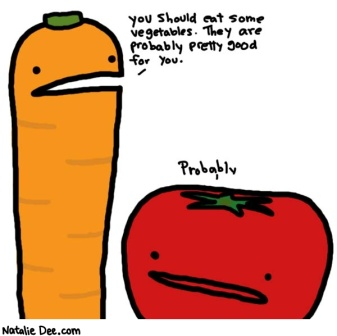Imagine the carrot and the tomato in a fantasy world. What kind of roles would they play? In a magical fantasy world, the carrot would be the wise and brave knight, armed with a sword made of iron-rich spinach and clad in armor crafted from the sturdiest beets. He would go by the name Sir Carrot, the Protector of Health, always ready to fight off evil junk food forces threatening the Kingdom of Nutritia.
The tomato would be the clever alchemist, known as Dr. Tomato, concocting powerful elixirs and potions from the finest garden herbs and spices. Using his vast knowledge, he would assist Sir Carrot on their quests, providing crucial support with his healing brews and wisdom.
Together, they would embark on epic adventures, ensuring the land remains healthy and prosperous, educating its citizens about the importance of balanced nutrition along the way.  Describe what a day in the life of these vegetable heroes would be like on their adventure. Sir Carrot and Dr. Tomato started their day by planning their journey in the vibrant garden kingdom of Nutritia. They reviewed their map, identifying areas plagued by the Mischief of Processed Food Goblins. After a hearty breakfast of leafy greens and root vegetables, they set off on their quest.
Sir Carrot led with strength and valor, his armor gleaming in the sunlight. He used his spinach sword to clear any obstacles and protect their path. Meanwhile, Dr. Tomato worked tirelessly to mix powerful potions from the garden flora, ready to restore their energy if needed.
As they traveled, they encountered citizens who needed their help. For instance, they met a group of young sprouts (baby veggies) feeling weak and tired. Dr. Tomato quickly brewed a vitamin-rich smoothie, instantly rejuvenating them. Sir Carrot offered advice on maintaining a nutritious diet as they continued forward.
By midday, they reached the lair of the Processed Food Goblins. With Sir Carrot's bravery and Dr. Tomato's cunning, they overwhelmed the goblins, replacing unhealthy snacks with nutritious alternatives. Victorious, they returned to the kingdom, celebrated by the residents of Nutritia, ensuring another day of health and happiness for all.
In the evening, they prepared for the next day's journey, continually committed to preserving the well-being of their beloved land. 